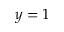Convert formula to latex. <formula><loc_0><loc_0><loc_500><loc_500>y = 1</formula> 